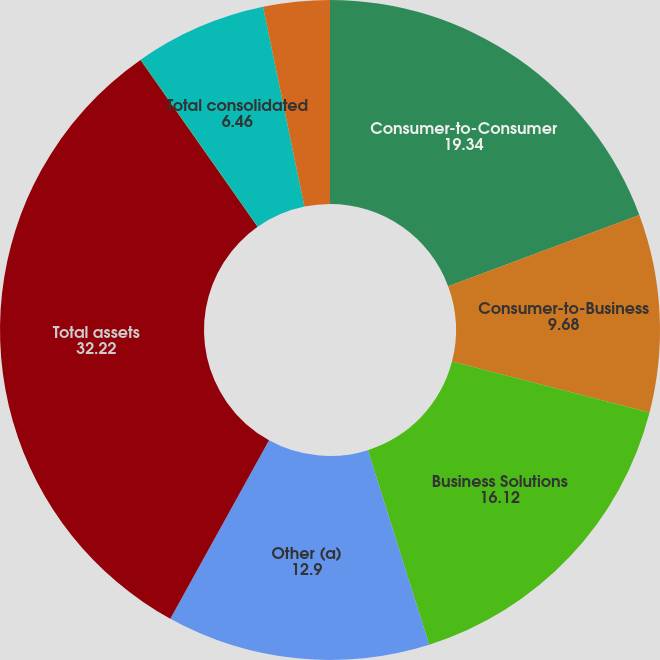Convert chart. <chart><loc_0><loc_0><loc_500><loc_500><pie_chart><fcel>Consumer-to-Consumer<fcel>Consumer-to-Business<fcel>Business Solutions<fcel>Other (a)<fcel>Total assets<fcel>Other<fcel>Total consolidated<fcel>Total capital expenditures<nl><fcel>19.34%<fcel>9.68%<fcel>16.12%<fcel>12.9%<fcel>32.22%<fcel>0.03%<fcel>6.46%<fcel>3.25%<nl></chart> 